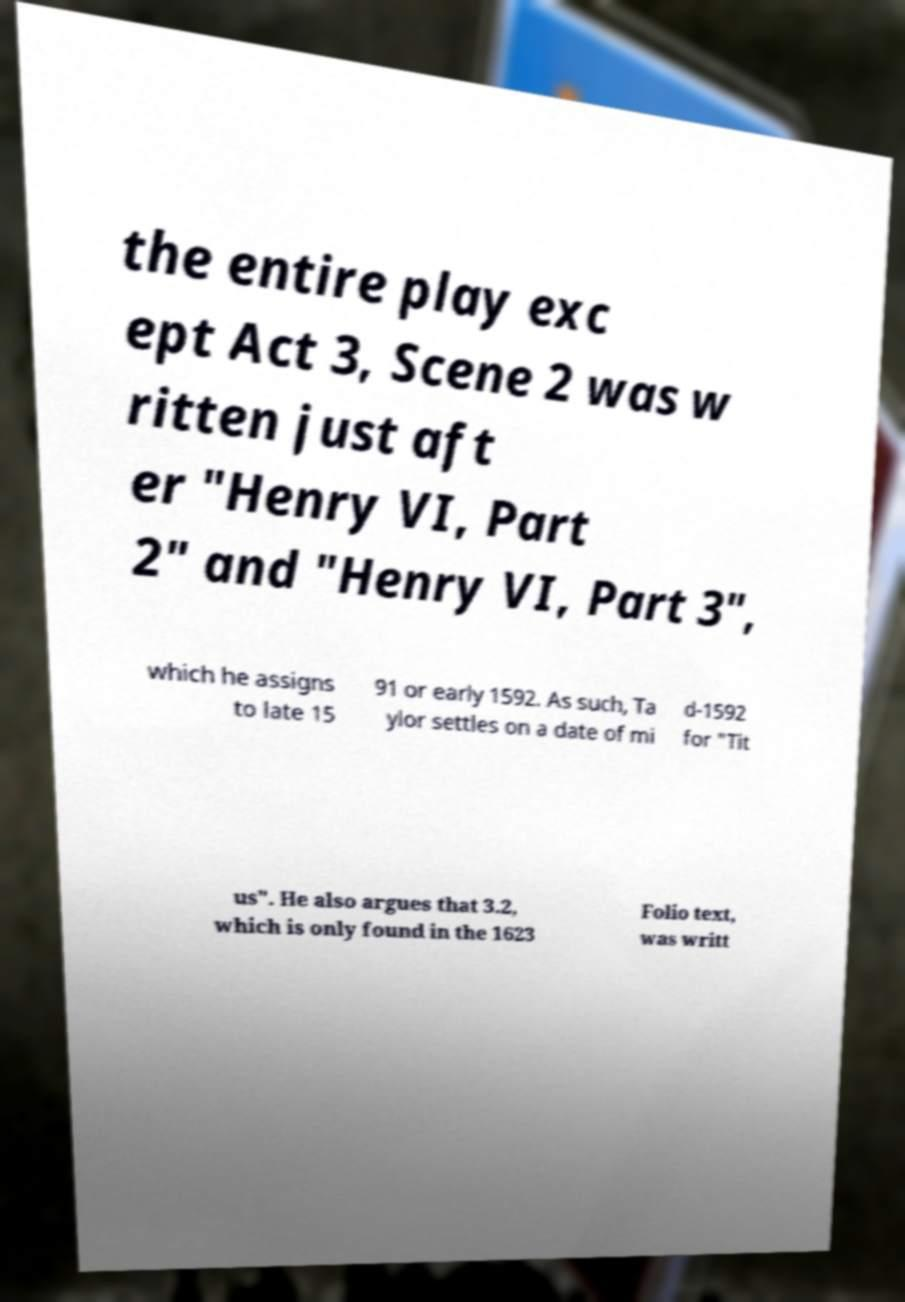Please identify and transcribe the text found in this image. the entire play exc ept Act 3, Scene 2 was w ritten just aft er "Henry VI, Part 2" and "Henry VI, Part 3", which he assigns to late 15 91 or early 1592. As such, Ta ylor settles on a date of mi d-1592 for "Tit us". He also argues that 3.2, which is only found in the 1623 Folio text, was writt 